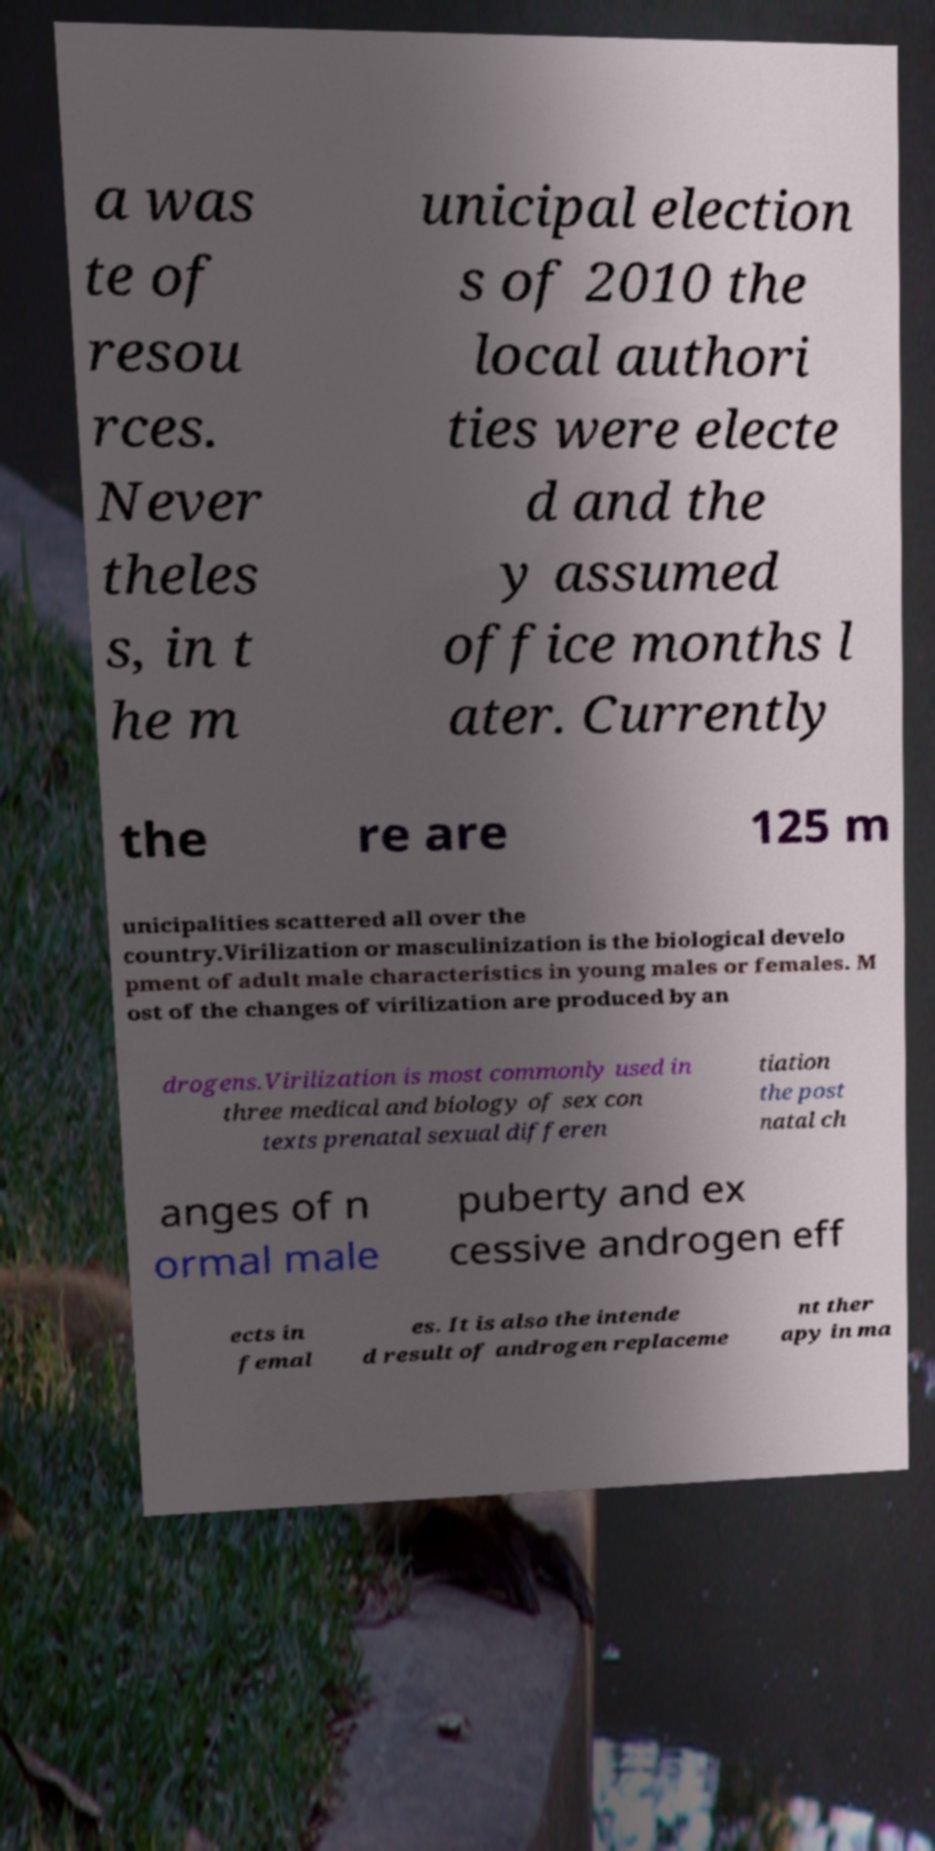Can you read and provide the text displayed in the image?This photo seems to have some interesting text. Can you extract and type it out for me? a was te of resou rces. Never theles s, in t he m unicipal election s of 2010 the local authori ties were electe d and the y assumed office months l ater. Currently the re are 125 m unicipalities scattered all over the country.Virilization or masculinization is the biological develo pment of adult male characteristics in young males or females. M ost of the changes of virilization are produced by an drogens.Virilization is most commonly used in three medical and biology of sex con texts prenatal sexual differen tiation the post natal ch anges of n ormal male puberty and ex cessive androgen eff ects in femal es. It is also the intende d result of androgen replaceme nt ther apy in ma 